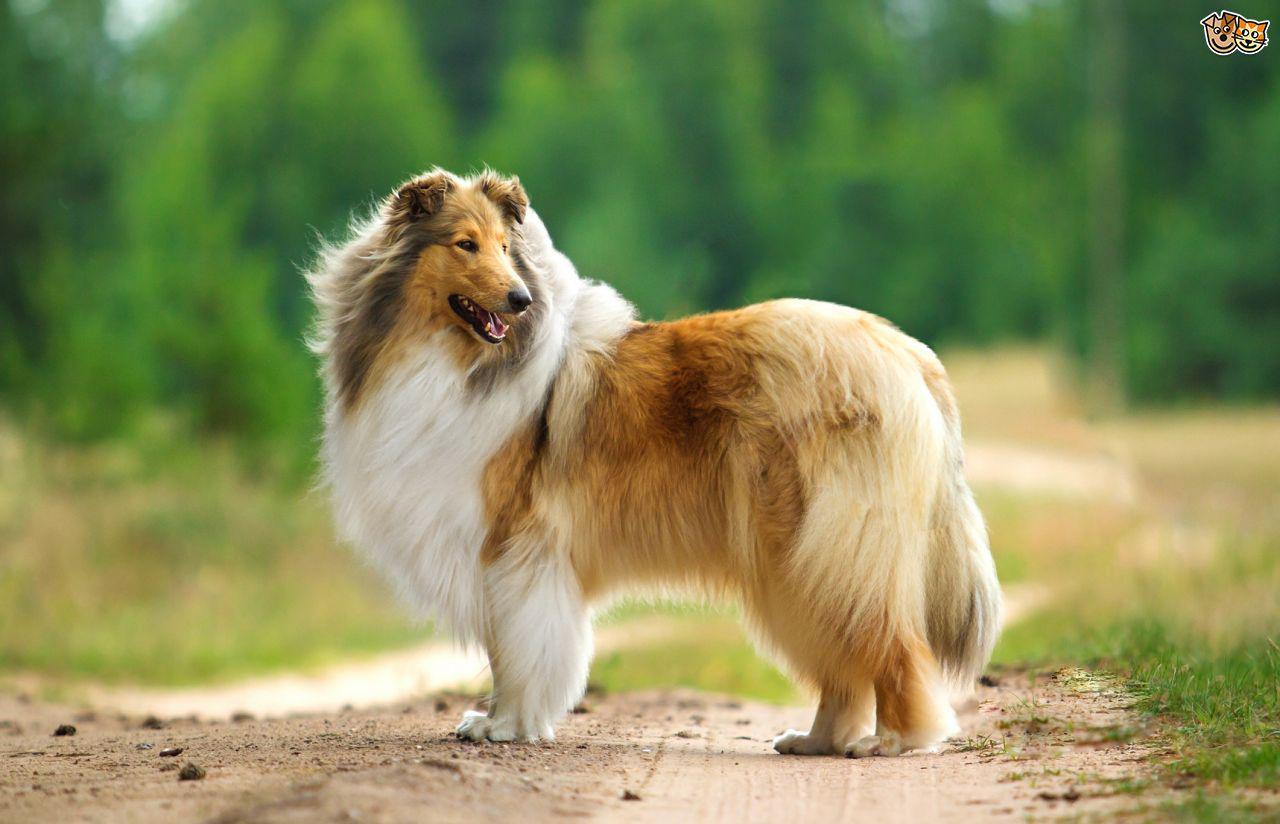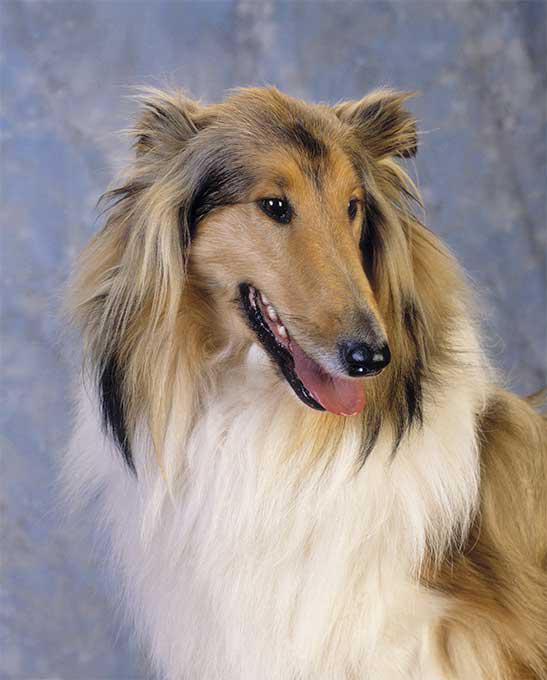The first image is the image on the left, the second image is the image on the right. Examine the images to the left and right. Is the description "One image shows a collie standing on grass, and the other is a portrait." accurate? Answer yes or no. Yes. 